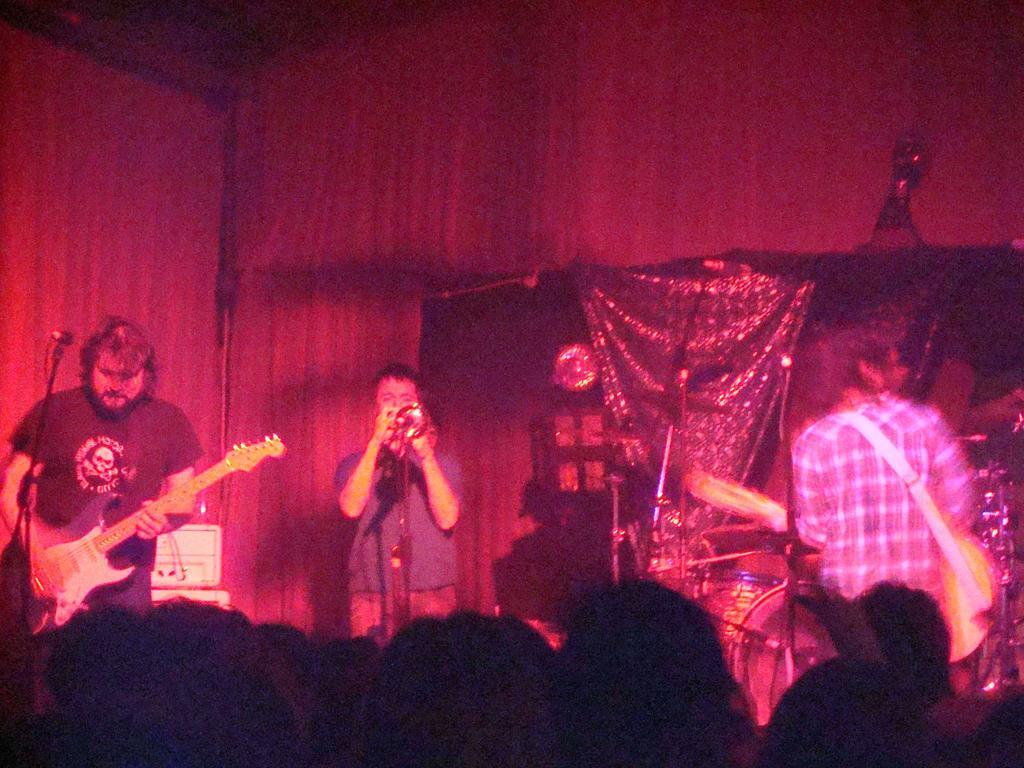How many people are in the image? There are people in the image. What are the people doing in the image? One person is playing a guitar, and another person is playing a trumpet. What type of plants can be seen growing in the caption of the image? There is no caption present in the image, and therefore no plants can be seen growing in it. 